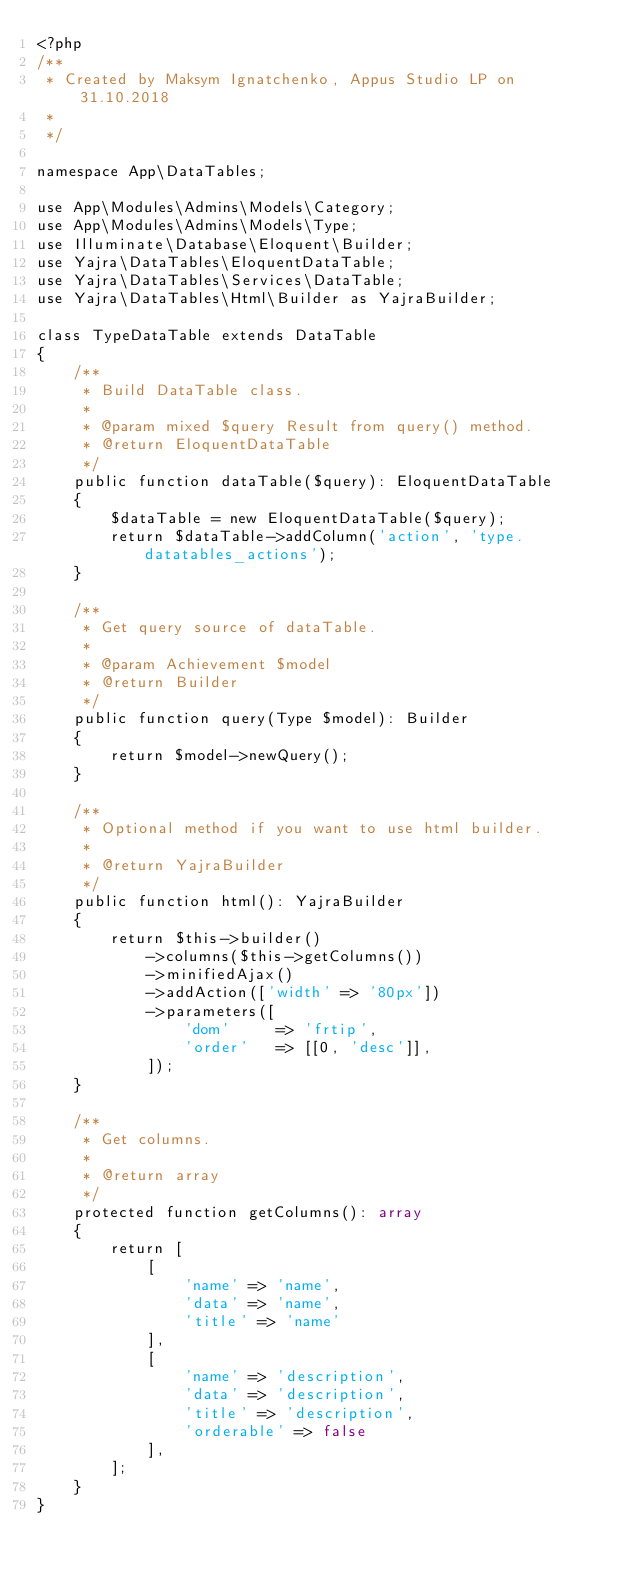Convert code to text. <code><loc_0><loc_0><loc_500><loc_500><_PHP_><?php
/**
 * Created by Maksym Ignatchenko, Appus Studio LP on 31.10.2018
 *
 */

namespace App\DataTables;

use App\Modules\Admins\Models\Category;
use App\Modules\Admins\Models\Type;
use Illuminate\Database\Eloquent\Builder;
use Yajra\DataTables\EloquentDataTable;
use Yajra\DataTables\Services\DataTable;
use Yajra\DataTables\Html\Builder as YajraBuilder;

class TypeDataTable extends DataTable
{
    /**
     * Build DataTable class.
     *
     * @param mixed $query Result from query() method.
     * @return EloquentDataTable
     */
    public function dataTable($query): EloquentDataTable
    {
        $dataTable = new EloquentDataTable($query);
        return $dataTable->addColumn('action', 'type.datatables_actions');
    }

    /**
     * Get query source of dataTable.
     *
     * @param Achievement $model
     * @return Builder
     */
    public function query(Type $model): Builder
    {
        return $model->newQuery();
    }

    /**
     * Optional method if you want to use html builder.
     *
     * @return YajraBuilder
     */
    public function html(): YajraBuilder
    {
        return $this->builder()
            ->columns($this->getColumns())
            ->minifiedAjax()
            ->addAction(['width' => '80px'])
            ->parameters([
                'dom'     => 'frtip',
                'order'   => [[0, 'desc']],
            ]);
    }

    /**
     * Get columns.
     *
     * @return array
     */
    protected function getColumns(): array
    {
        return [
            [
                'name' => 'name',
                'data' => 'name',
                'title' => 'name'
            ],
            [
                'name' => 'description',
                'data' => 'description',
                'title' => 'description',
                'orderable' => false
            ],
        ];
    }
}</code> 